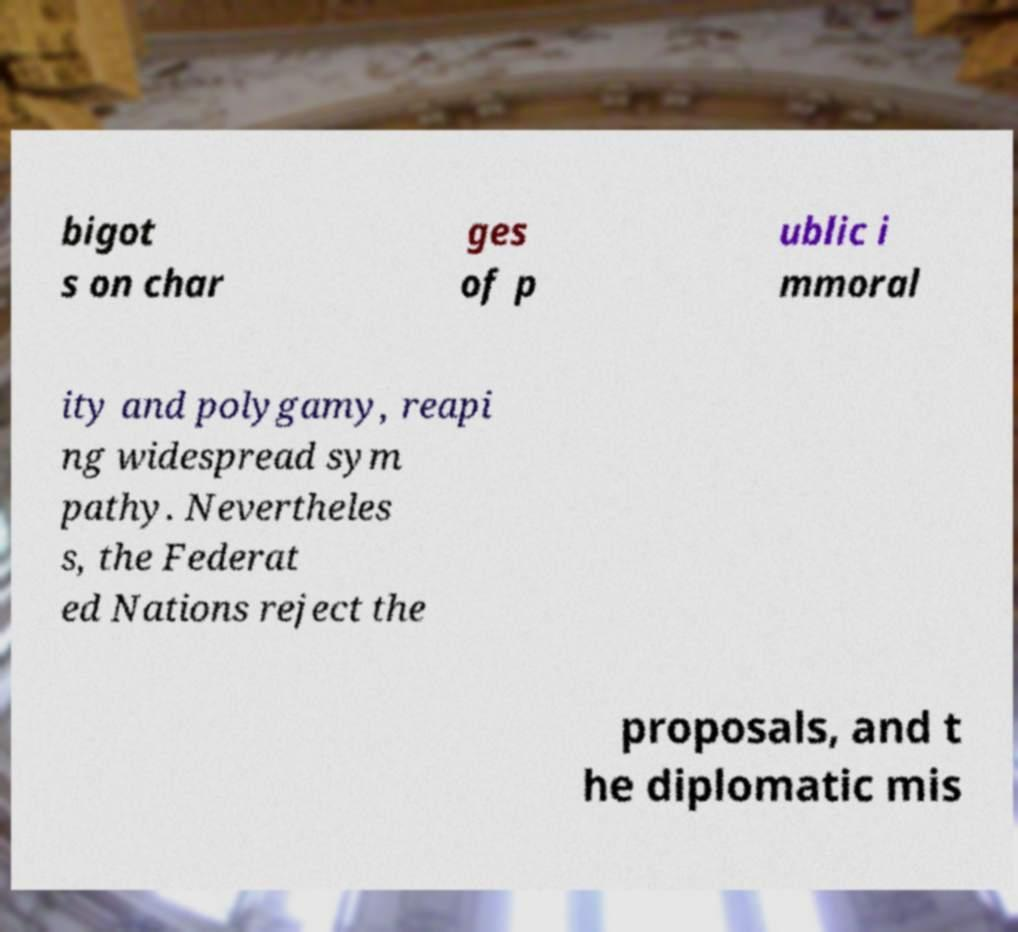Please identify and transcribe the text found in this image. bigot s on char ges of p ublic i mmoral ity and polygamy, reapi ng widespread sym pathy. Nevertheles s, the Federat ed Nations reject the proposals, and t he diplomatic mis 